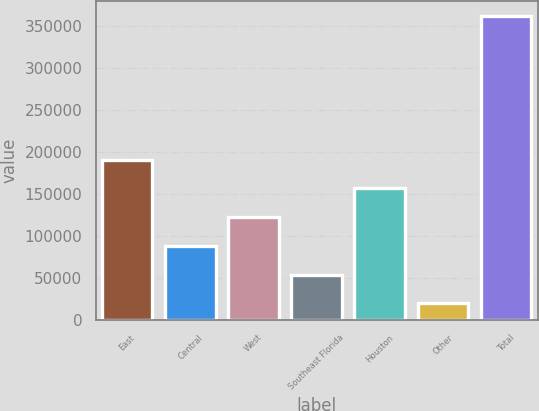Convert chart. <chart><loc_0><loc_0><loc_500><loc_500><bar_chart><fcel>East<fcel>Central<fcel>West<fcel>Southeast Florida<fcel>Houston<fcel>Other<fcel>Total<nl><fcel>190578<fcel>87883.6<fcel>122115<fcel>53652.3<fcel>156346<fcel>19421<fcel>361734<nl></chart> 